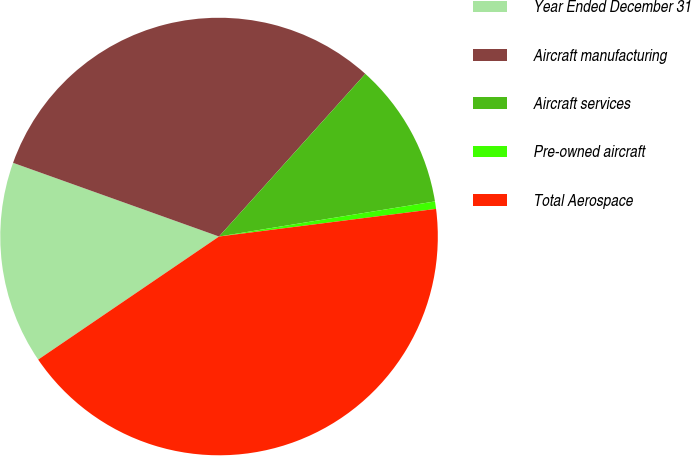<chart> <loc_0><loc_0><loc_500><loc_500><pie_chart><fcel>Year Ended December 31<fcel>Aircraft manufacturing<fcel>Aircraft services<fcel>Pre-owned aircraft<fcel>Total Aerospace<nl><fcel>14.98%<fcel>31.19%<fcel>10.78%<fcel>0.55%<fcel>42.51%<nl></chart> 